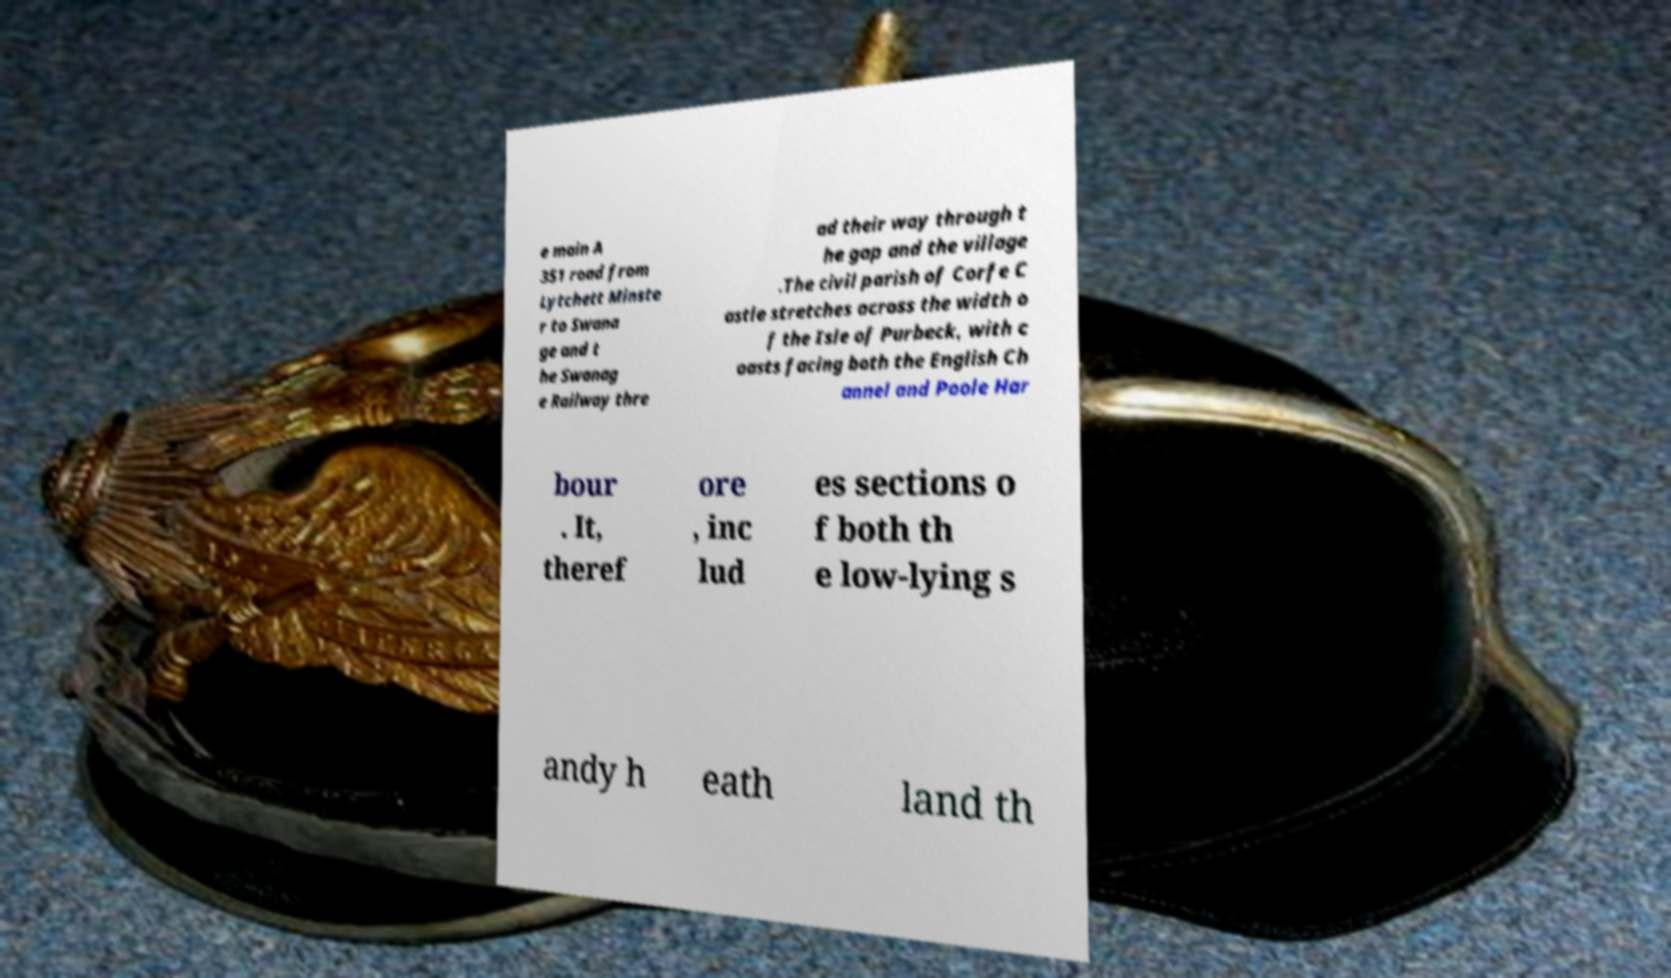Can you accurately transcribe the text from the provided image for me? e main A 351 road from Lytchett Minste r to Swana ge and t he Swanag e Railway thre ad their way through t he gap and the village .The civil parish of Corfe C astle stretches across the width o f the Isle of Purbeck, with c oasts facing both the English Ch annel and Poole Har bour . It, theref ore , inc lud es sections o f both th e low-lying s andy h eath land th 